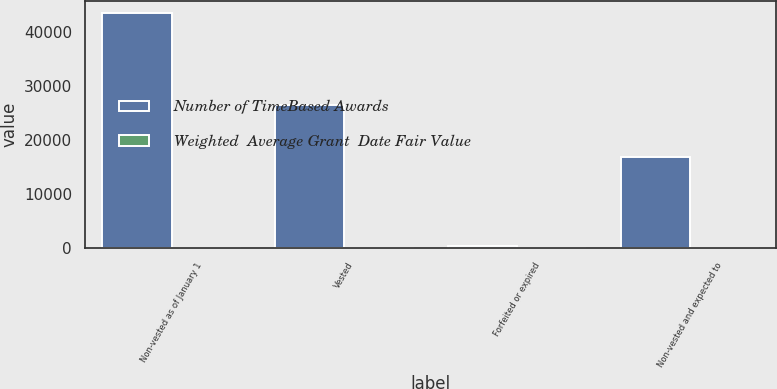Convert chart. <chart><loc_0><loc_0><loc_500><loc_500><stacked_bar_chart><ecel><fcel>Non-vested as of January 1<fcel>Vested<fcel>Forfeited or expired<fcel>Non-vested and expected to<nl><fcel>Number of TimeBased Awards<fcel>43653<fcel>26429<fcel>352<fcel>16872<nl><fcel>Weighted  Average Grant  Date Fair Value<fcel>5.87<fcel>4.79<fcel>2.5<fcel>7.63<nl></chart> 